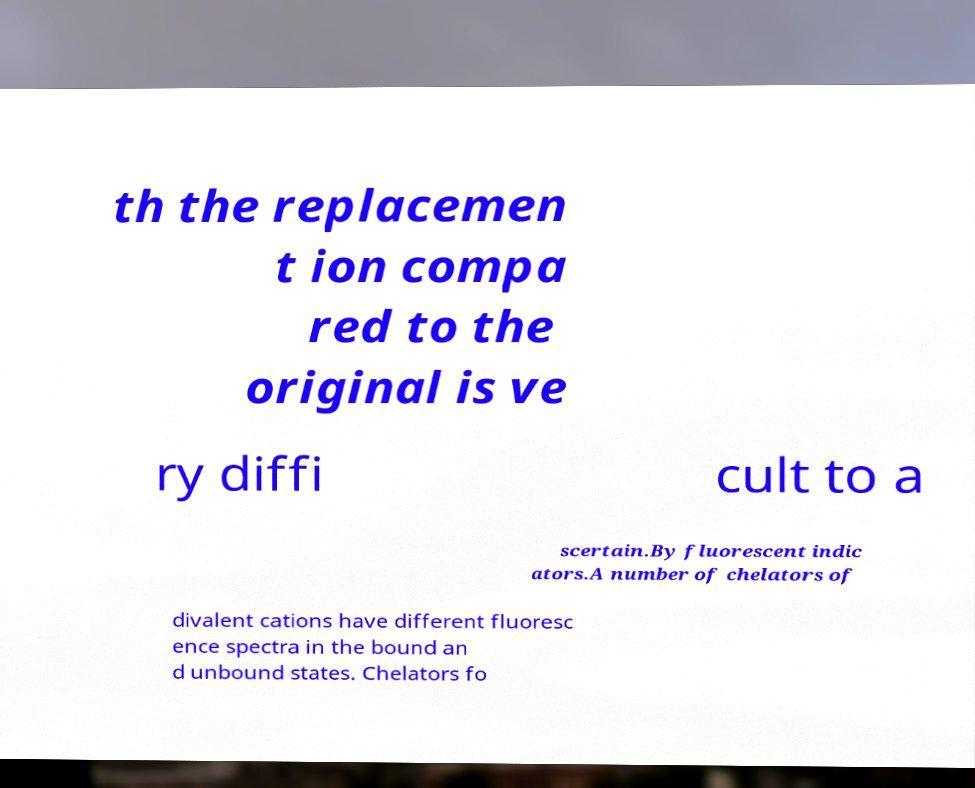For documentation purposes, I need the text within this image transcribed. Could you provide that? th the replacemen t ion compa red to the original is ve ry diffi cult to a scertain.By fluorescent indic ators.A number of chelators of divalent cations have different fluoresc ence spectra in the bound an d unbound states. Chelators fo 